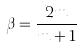<formula> <loc_0><loc_0><loc_500><loc_500>\beta = \frac { 2 m } { m + 1 }</formula> 